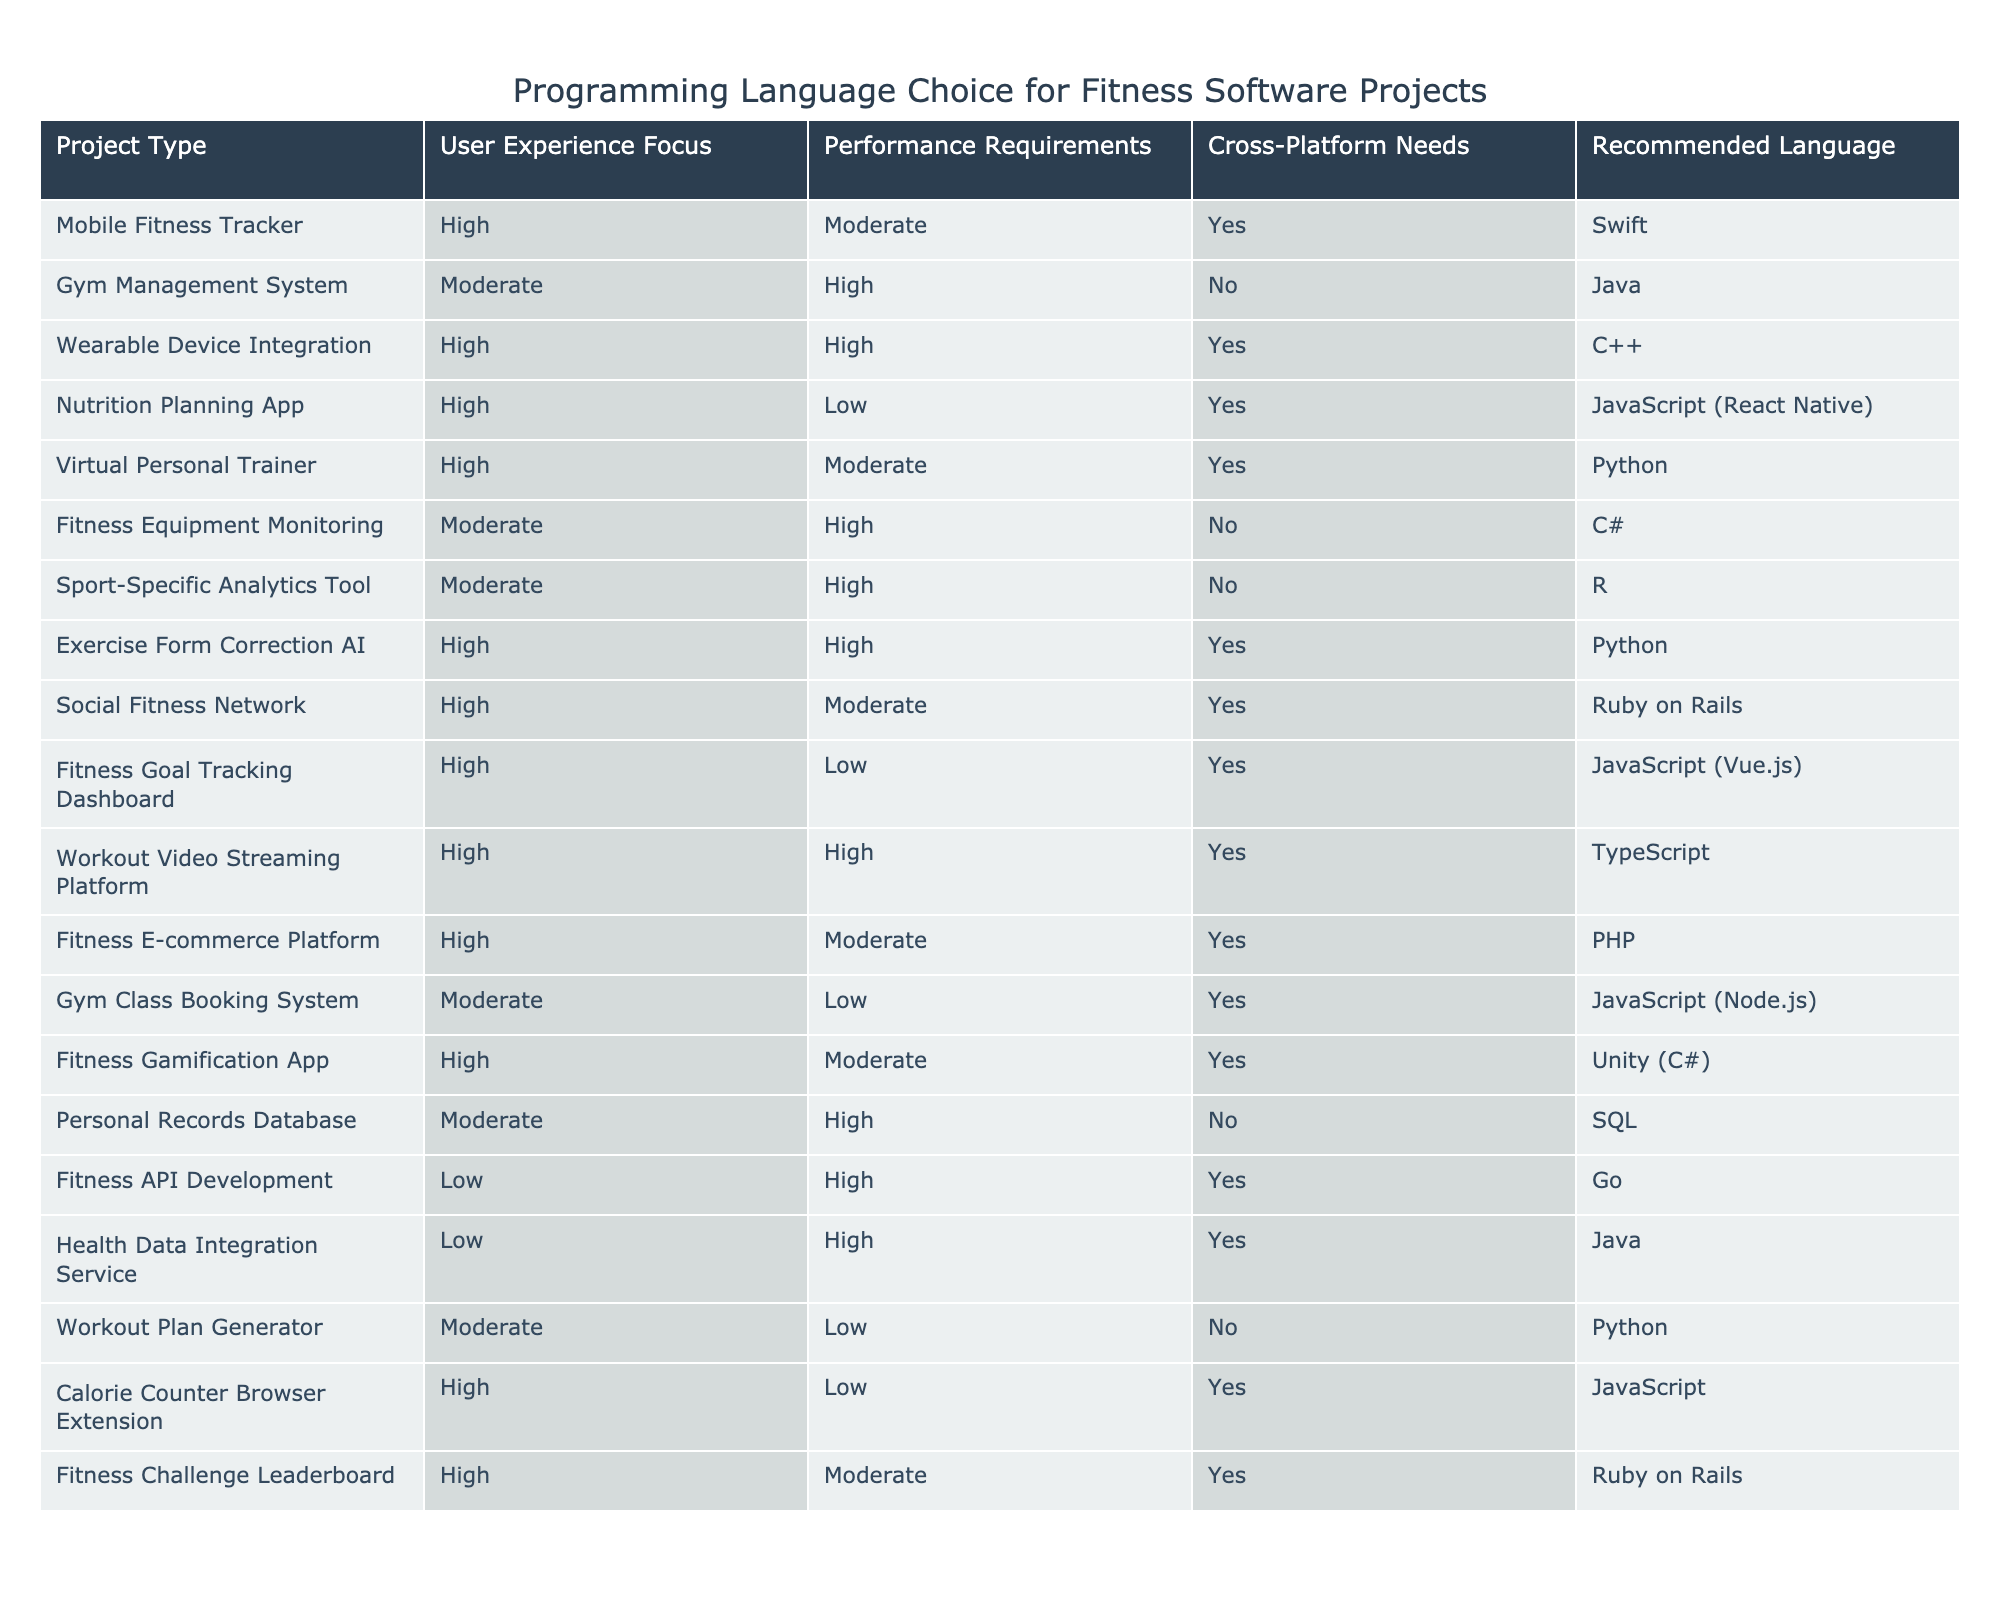What programming language is recommended for a Mobile Fitness Tracker? The table lists the recommended language for a Mobile Fitness Tracker under the "Recommended Language" column. It states "Swift" as the recommended language.
Answer: Swift How many projects have high user experience focus? By examining the "User Experience Focus" column, we can count how many projects are categorized as "High." There are 8 projects that have a high user experience focus.
Answer: 8 Is C++ recommended for any projects that require cross-platform needs? The table indicates whether each project requires cross-platform compatibility. C++ is recommended for "Wearable Device Integration," which is noted as requiring cross-platform capability. Thus, the answer is yes.
Answer: Yes Which programming language is recommended for the Fitness API Development project? We look at the specific row for "Fitness API Development" and find the corresponding recommended language, which is "Go."
Answer: Go What is the ratio of projects that have a high performance requirement versus those that have a low performance requirement? To find this ratio, we count the projects under "High" performance (6 projects) and those under "Low" performance (3 projects). The ratio is 6:3, which simplifies to 2:1.
Answer: 2:1 Are there any projects listed that do not focus on user experience? By reviewing the "User Experience Focus" column, we see that there are 2 projects — "Personal Records Database" and "Workout Plan Generator" — which are categorized as "Moderate" or "Low," indicating they do not focus on high user experience.
Answer: Yes Which programming language is used for the Exercise Form Correction AI project? Referring to the row for "Exercise Form Correction AI," we can identify that it is recommended to use "Python."
Answer: Python How many projects utilize JavaScript in their development? By counting the entries in the "Recommended Language" column that include "JavaScript," we find there are 4 projects: Nutrition Planning App, Fitness Goal Tracking Dashboard, Calorie Counter Browser Extension, and Gym Class Booking System.
Answer: 4 What is the total number of projects that do not need cross-platform support? Looking at the "Cross-Platform Needs" column, we can count that there are 6 projects marked as "No," indicating they do not require cross-platform support.
Answer: 6 